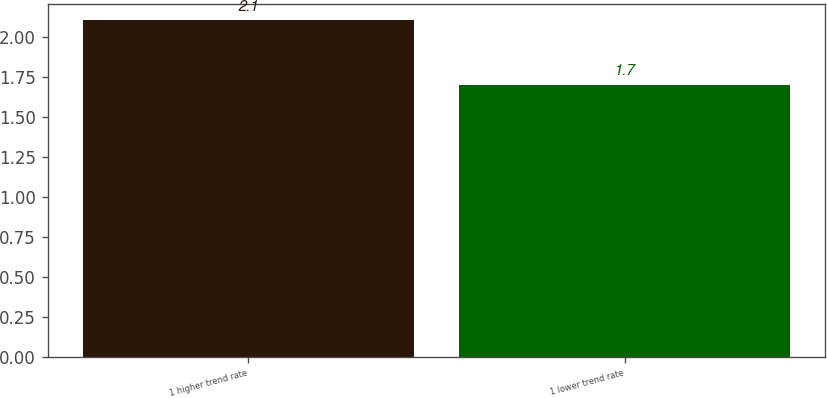Convert chart. <chart><loc_0><loc_0><loc_500><loc_500><bar_chart><fcel>1 higher trend rate<fcel>1 lower trend rate<nl><fcel>2.1<fcel>1.7<nl></chart> 